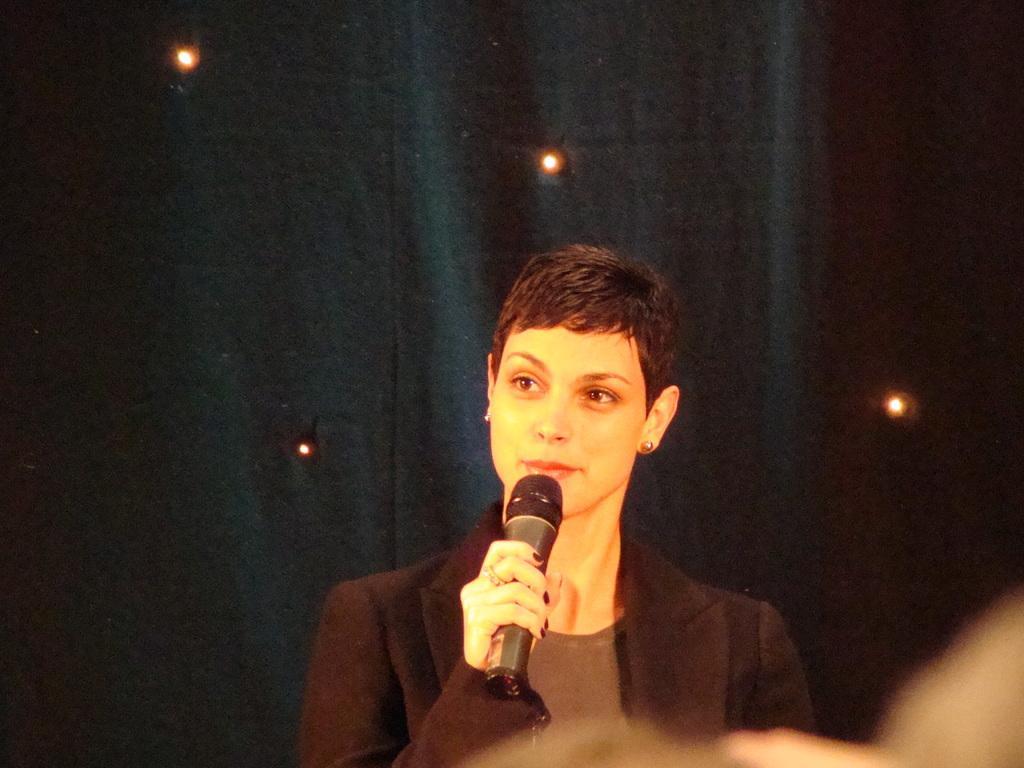Please provide a concise description of this image. This person is holding a mic and wore a suit. Background there are lights and curtain.   